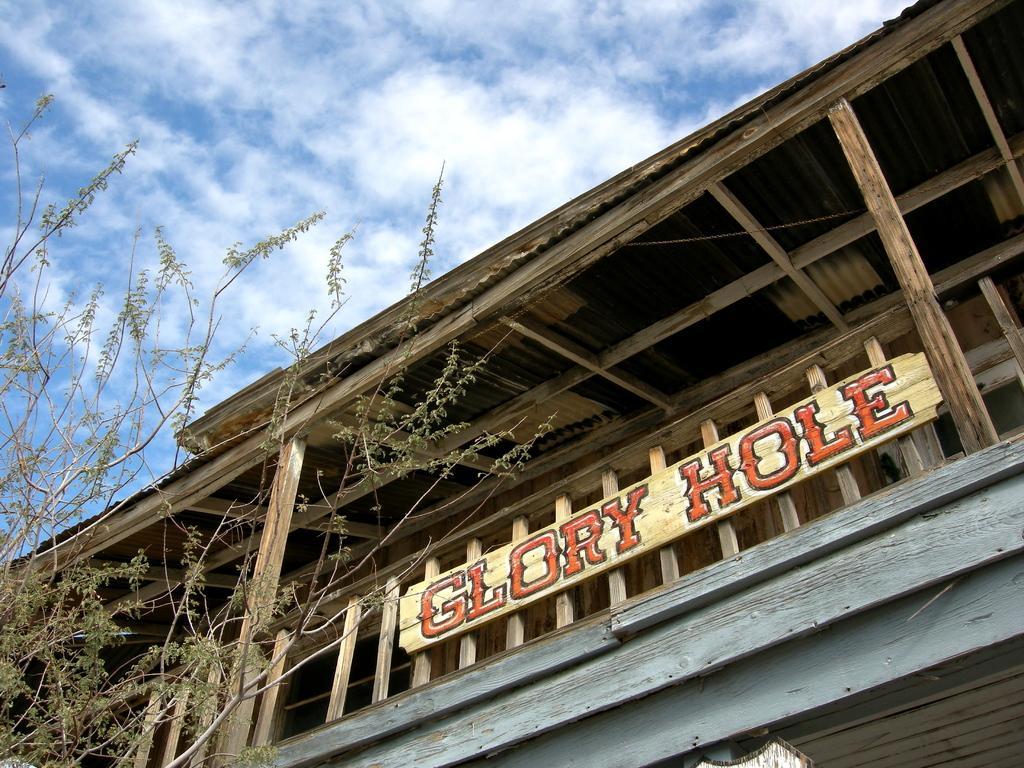Please provide a concise description of this image. On the left side, we see the trees. At the bottom, we see a wooden building in grey color. In the middle, we see a wooden board with some text written as "GLORY HOLE". In the background, we see a wooden building. At the top, we see the clouds and the sky. 